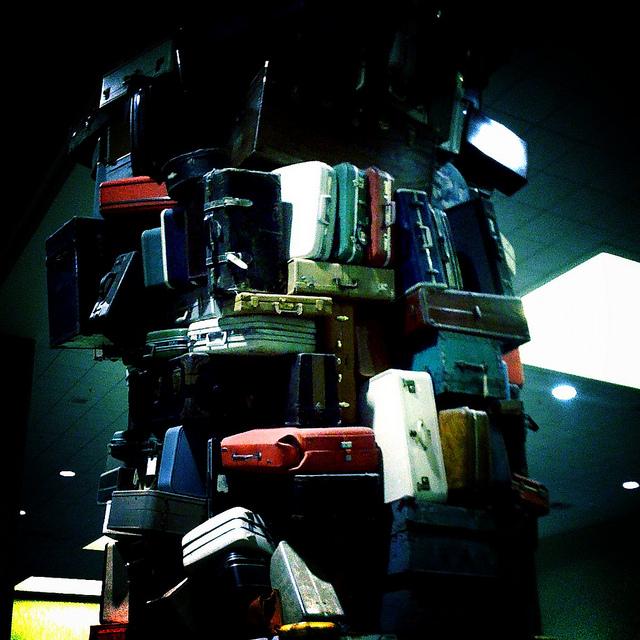How many red cases are there?
Quick response, please. 2. What color are the luggages?
Give a very brief answer. Many colors. How many luggage are stacked in the picture?
Give a very brief answer. Several. 